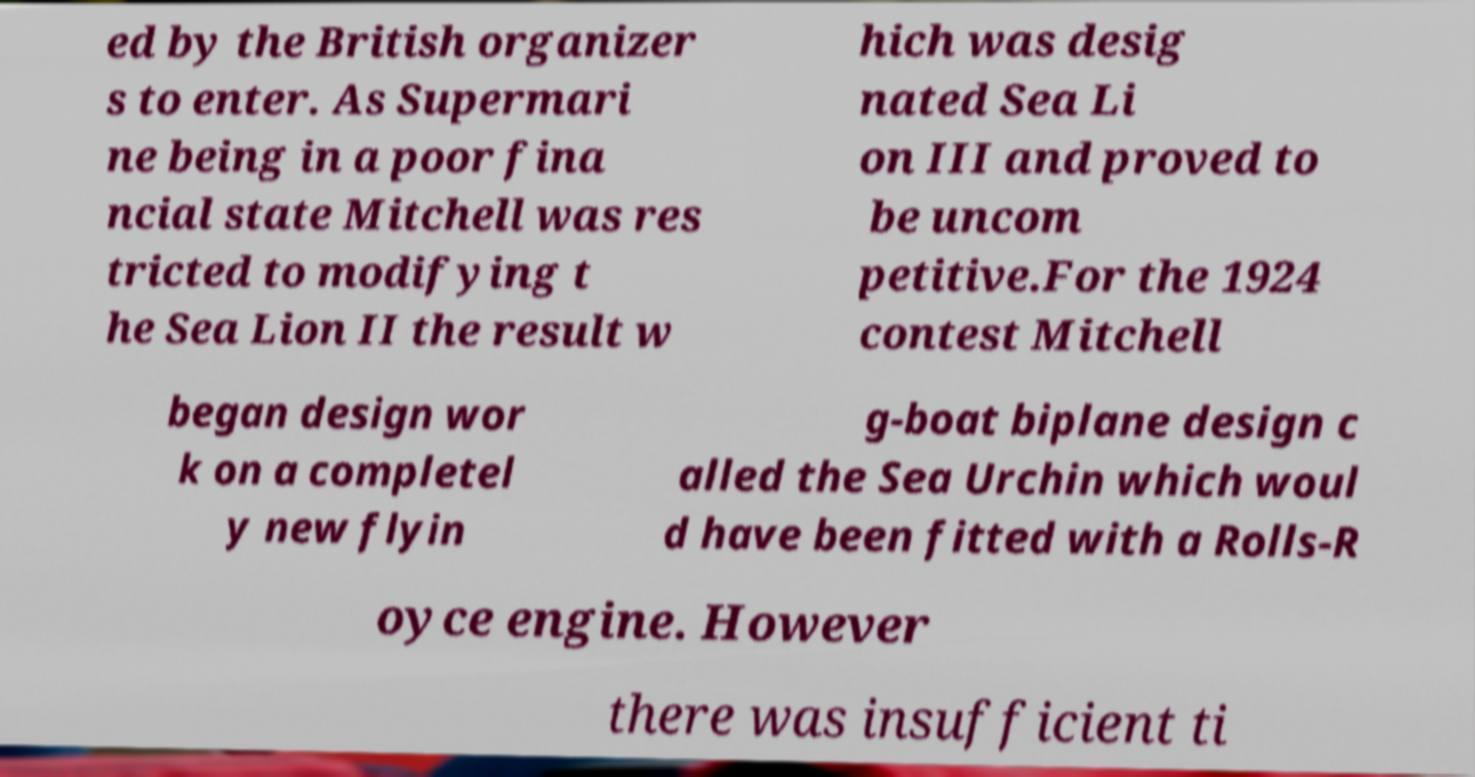Can you read and provide the text displayed in the image?This photo seems to have some interesting text. Can you extract and type it out for me? ed by the British organizer s to enter. As Supermari ne being in a poor fina ncial state Mitchell was res tricted to modifying t he Sea Lion II the result w hich was desig nated Sea Li on III and proved to be uncom petitive.For the 1924 contest Mitchell began design wor k on a completel y new flyin g-boat biplane design c alled the Sea Urchin which woul d have been fitted with a Rolls-R oyce engine. However there was insufficient ti 